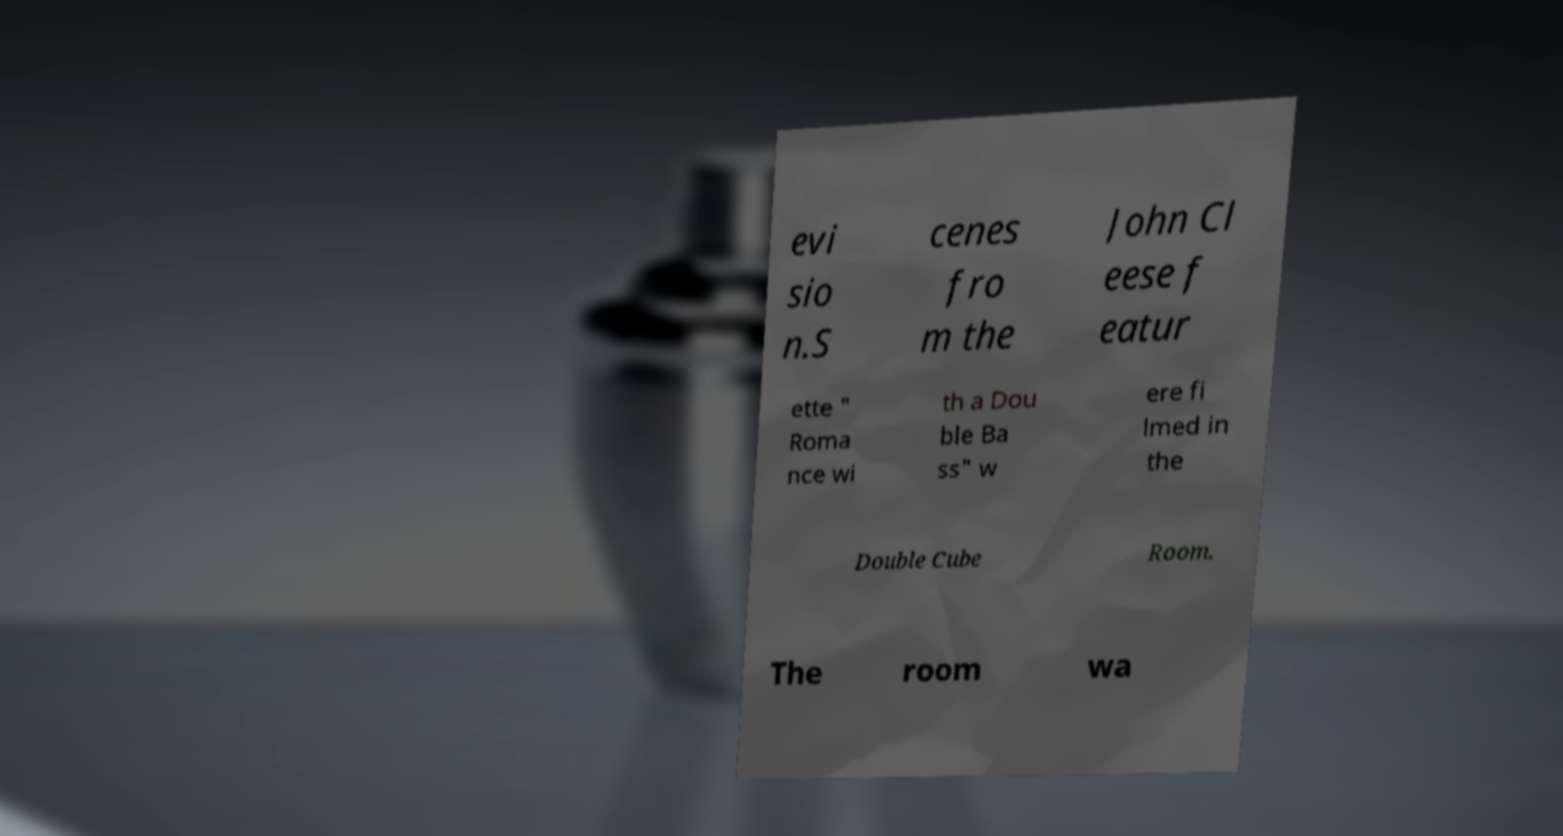Please identify and transcribe the text found in this image. evi sio n.S cenes fro m the John Cl eese f eatur ette " Roma nce wi th a Dou ble Ba ss" w ere fi lmed in the Double Cube Room. The room wa 